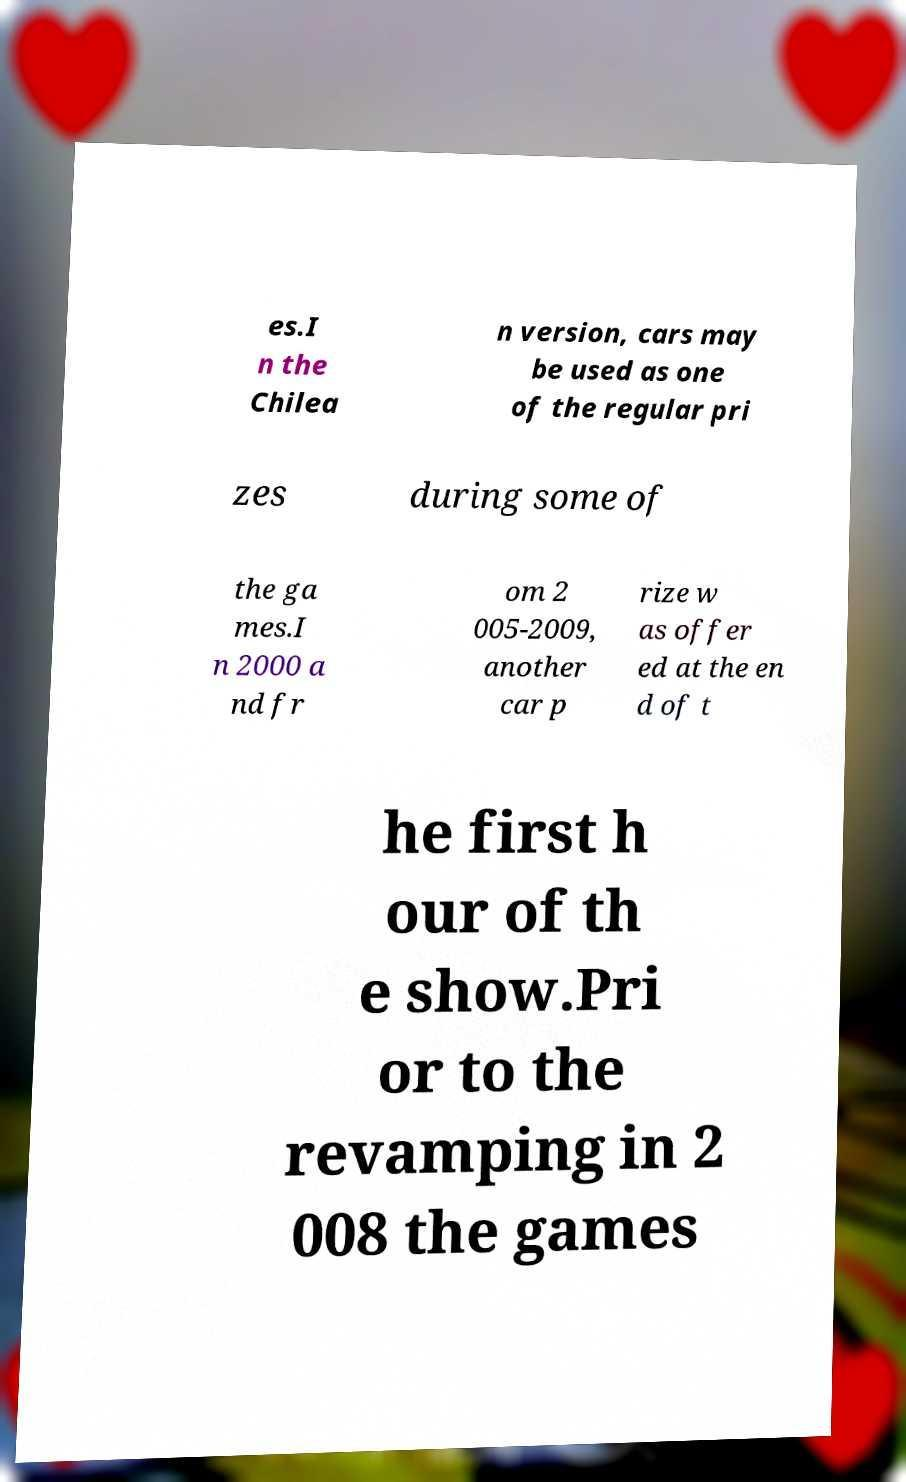Could you assist in decoding the text presented in this image and type it out clearly? es.I n the Chilea n version, cars may be used as one of the regular pri zes during some of the ga mes.I n 2000 a nd fr om 2 005-2009, another car p rize w as offer ed at the en d of t he first h our of th e show.Pri or to the revamping in 2 008 the games 